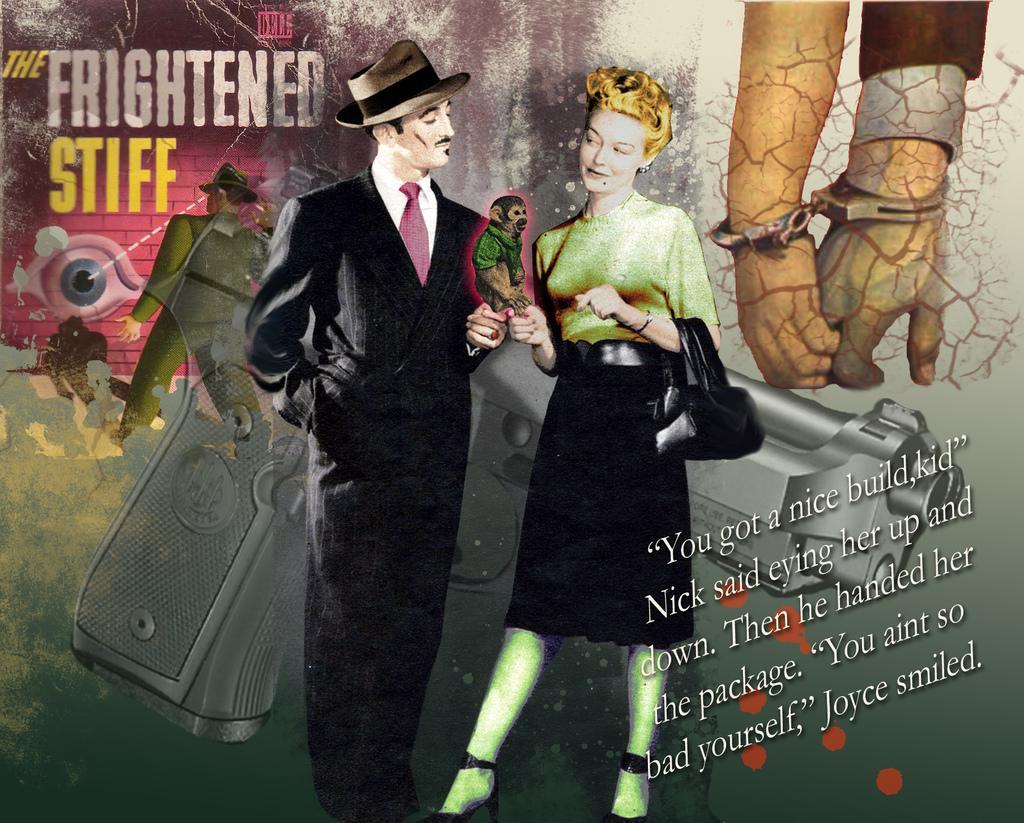Can you describe this image briefly? In this picture there is a poster. In the center there is a man who is wearing hat, suit and shoe. Beside him there is a woman who is wearing t-shirt and she is holding a bag and monkey. Behind them there is a gun. In the top right I can see two person's hand who are wearing hand-gloves. On the left there is an eye on the wall. In the bottom right there is a quotation. 